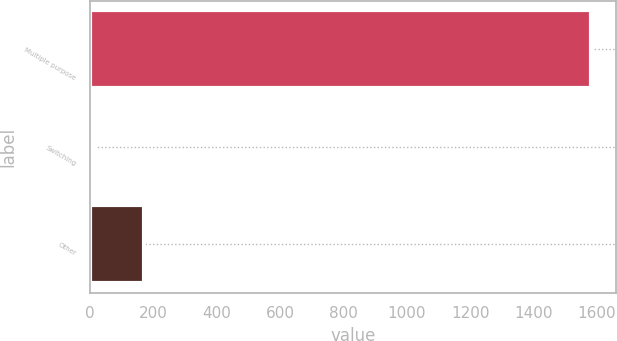Convert chart. <chart><loc_0><loc_0><loc_500><loc_500><bar_chart><fcel>Multiple purpose<fcel>Switching<fcel>Other<nl><fcel>1582<fcel>12<fcel>169<nl></chart> 